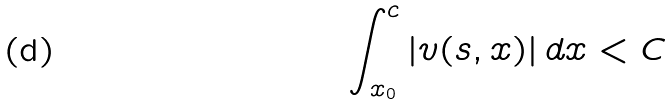Convert formula to latex. <formula><loc_0><loc_0><loc_500><loc_500>\int _ { x _ { 0 } } ^ { c } | v ( s , x ) | \, d x < C</formula> 